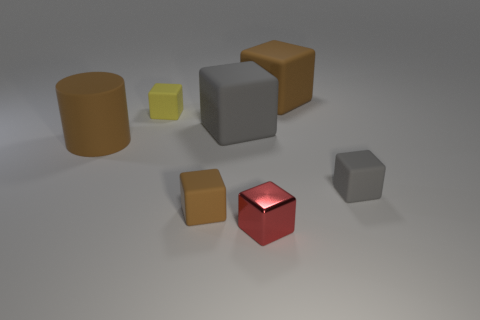Are there any other things that have the same material as the small red object?
Your answer should be compact. No. The small block that is in front of the tiny gray rubber block and behind the red shiny cube is made of what material?
Provide a short and direct response. Rubber. Is the material of the gray object that is to the right of the red shiny block the same as the red thing that is in front of the yellow object?
Keep it short and to the point. No. The cylinder has what size?
Offer a terse response. Large. What is the size of the other brown matte object that is the same shape as the tiny brown matte object?
Provide a short and direct response. Large. How many tiny red metallic blocks are to the left of the small yellow matte object?
Your answer should be compact. 0. What is the color of the small block that is right of the brown block that is to the right of the tiny brown rubber block?
Give a very brief answer. Gray. Is the number of small brown things that are right of the metal cube the same as the number of large brown rubber objects left of the small brown rubber object?
Your answer should be very brief. No. How many balls are shiny objects or gray matte objects?
Provide a succinct answer. 0. How many other things are there of the same material as the small gray thing?
Provide a succinct answer. 5. 